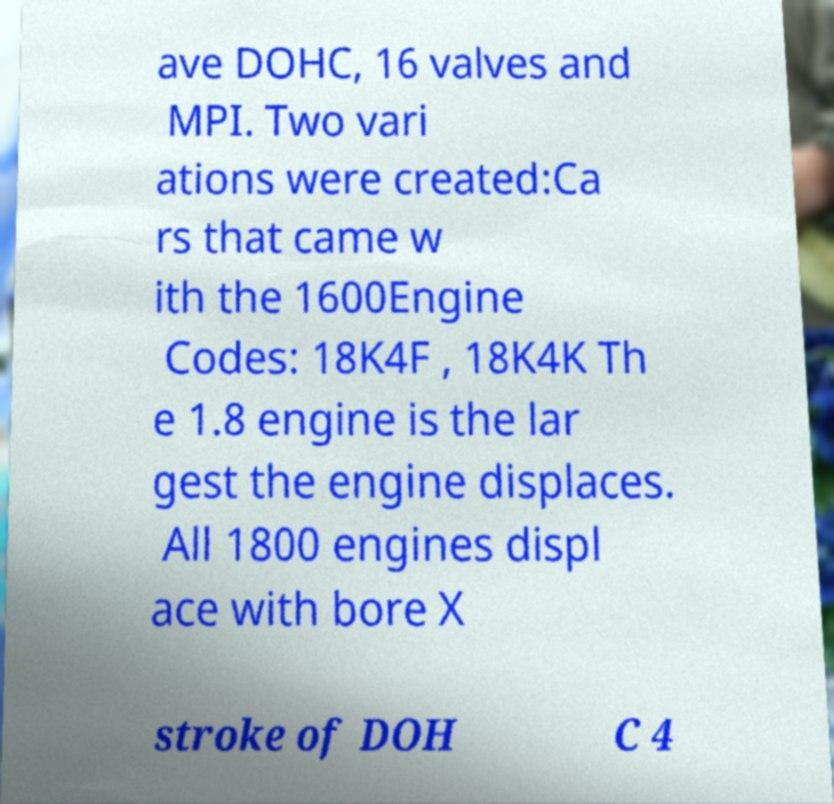What messages or text are displayed in this image? I need them in a readable, typed format. ave DOHC, 16 valves and MPI. Two vari ations were created:Ca rs that came w ith the 1600Engine Codes: 18K4F , 18K4K Th e 1.8 engine is the lar gest the engine displaces. All 1800 engines displ ace with bore X stroke of DOH C 4 